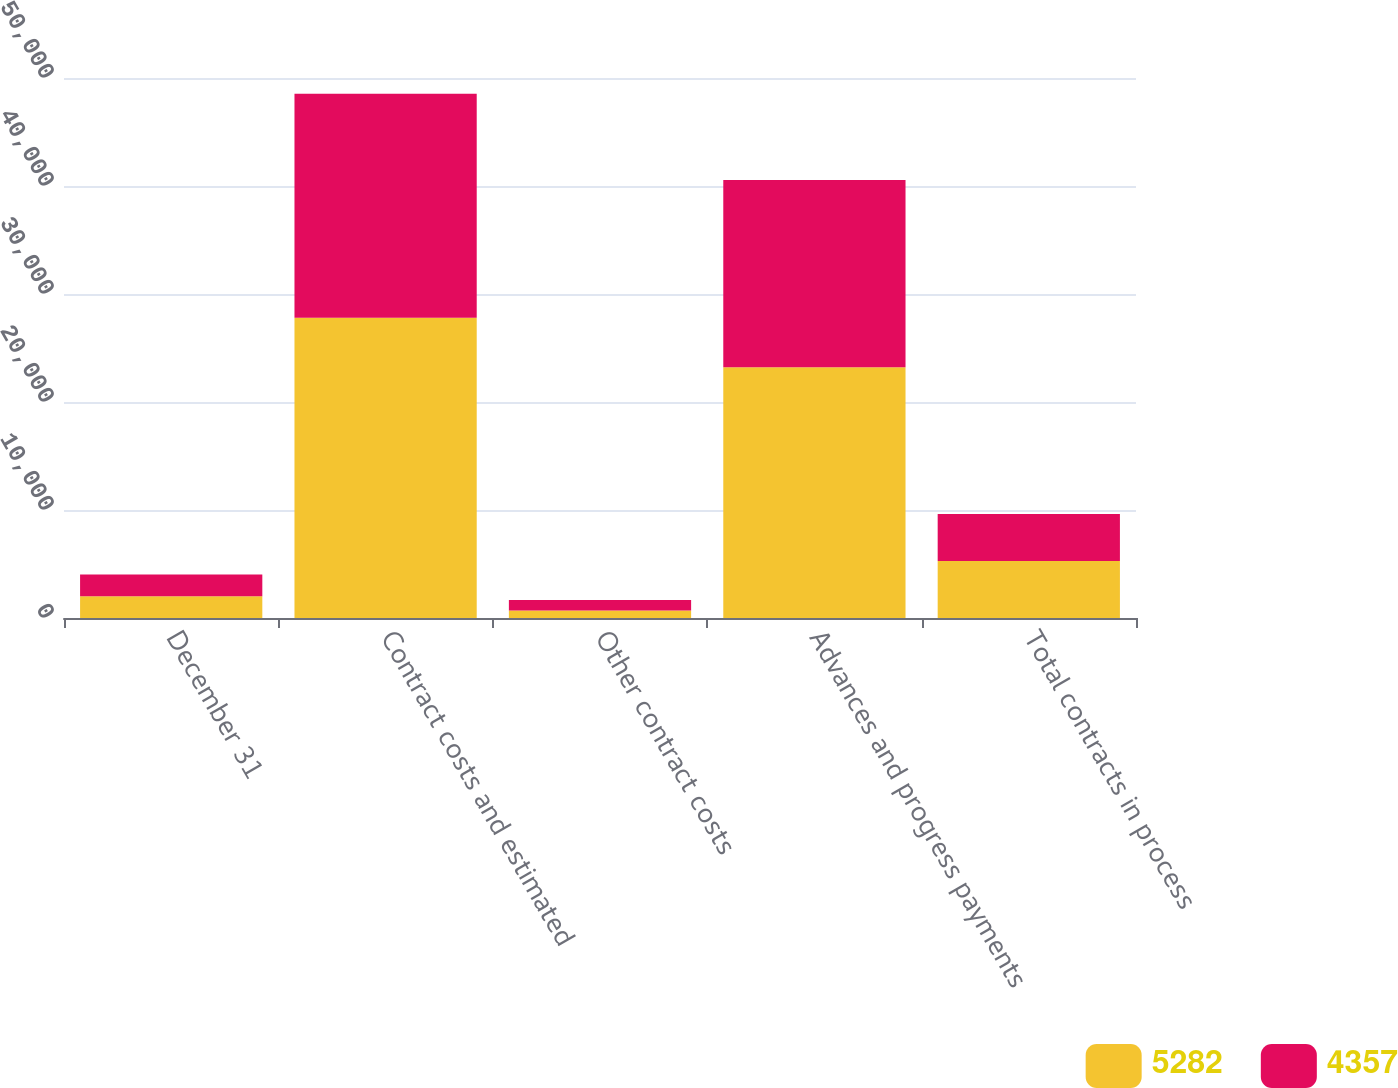Convert chart to OTSL. <chart><loc_0><loc_0><loc_500><loc_500><stacked_bar_chart><ecel><fcel>December 31<fcel>Contract costs and estimated<fcel>Other contract costs<fcel>Advances and progress payments<fcel>Total contracts in process<nl><fcel>5282<fcel>2016<fcel>27794<fcel>699<fcel>23211<fcel>5282<nl><fcel>4357<fcel>2015<fcel>20742<fcel>965<fcel>17350<fcel>4357<nl></chart> 